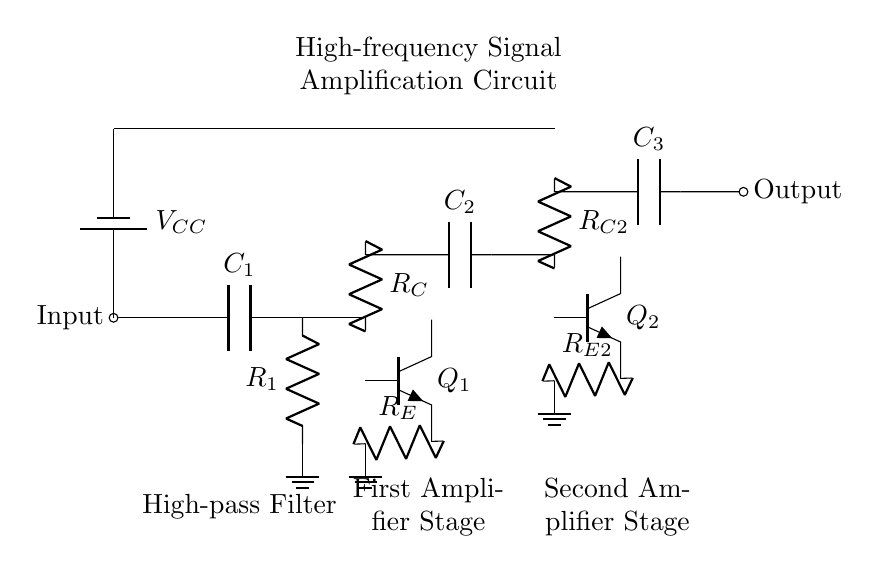What type of components are used in the first amplifier stage? The first amplifier stage uses a transistor, a resistor for collector, a resistor for emitter, and capacitors for coupling. The key components are Q1, R_C, R_E, and C2.
Answer: transistor, resistor, capacitor What is the role of the high-pass filter in the circuit? The high-pass filter, consisting of a capacitor and a resistor, is designed to block low-frequency signals and allow high-frequency signals to pass through, thereby improving signal quality.
Answer: block low-frequency signals How many amplifier stages are present in the circuit? There are two amplifier stages in the circuit, as indicated by the two distinct arrangements of the components labeled as "First Amplifier Stage" and "Second Amplifier Stage".
Answer: two What is the voltage supply in this circuit? The circuit has a voltage supply denoted as V_CC, which connects from the battery to the two amplifier stages, providing biasing for the transistors.
Answer: V_CC What would happen if the high-pass filter were omitted? Omitting the high-pass filter would allow low-frequency noise and signals to enter the amplifier stages, potentially leading to distortion and reduced amplification performance.
Answer: distortion Identify the component used to couple the stages together. The coupling between the stages occurs via the capacitors C2 and C3, which allow high-frequency signals to pass while blocking DC components, thus isolating the two amplifier stages.
Answer: capacitor 